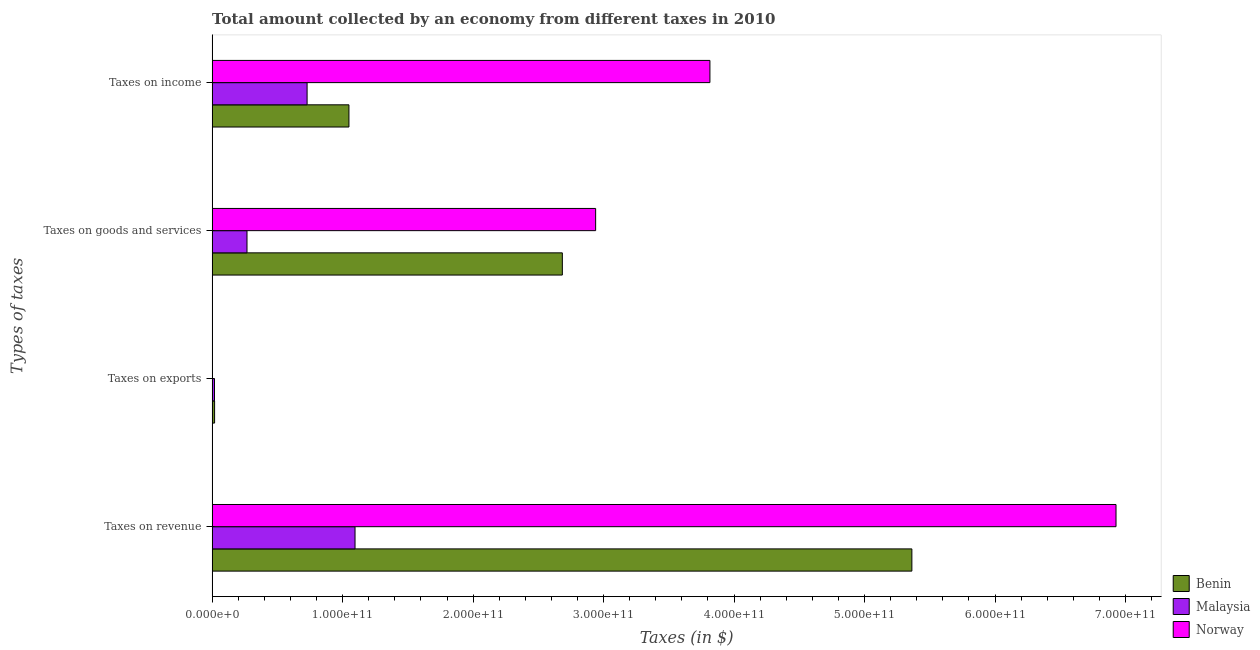How many groups of bars are there?
Keep it short and to the point. 4. Are the number of bars on each tick of the Y-axis equal?
Offer a terse response. Yes. What is the label of the 2nd group of bars from the top?
Provide a succinct answer. Taxes on goods and services. What is the amount collected as tax on income in Malaysia?
Your answer should be very brief. 7.28e+1. Across all countries, what is the maximum amount collected as tax on goods?
Provide a short and direct response. 2.94e+11. Across all countries, what is the minimum amount collected as tax on exports?
Your answer should be very brief. 1.50e+08. In which country was the amount collected as tax on exports maximum?
Your response must be concise. Benin. In which country was the amount collected as tax on income minimum?
Give a very brief answer. Malaysia. What is the total amount collected as tax on revenue in the graph?
Provide a succinct answer. 1.34e+12. What is the difference between the amount collected as tax on revenue in Malaysia and that in Norway?
Ensure brevity in your answer.  -5.83e+11. What is the difference between the amount collected as tax on revenue in Benin and the amount collected as tax on exports in Norway?
Offer a very short reply. 5.36e+11. What is the average amount collected as tax on goods per country?
Keep it short and to the point. 1.96e+11. What is the difference between the amount collected as tax on goods and amount collected as tax on income in Norway?
Your answer should be very brief. -8.76e+1. In how many countries, is the amount collected as tax on income greater than 700000000000 $?
Your answer should be compact. 0. What is the ratio of the amount collected as tax on revenue in Benin to that in Norway?
Provide a short and direct response. 0.77. Is the amount collected as tax on goods in Benin less than that in Malaysia?
Your answer should be compact. No. What is the difference between the highest and the second highest amount collected as tax on income?
Keep it short and to the point. 2.77e+11. What is the difference between the highest and the lowest amount collected as tax on exports?
Keep it short and to the point. 1.75e+09. In how many countries, is the amount collected as tax on exports greater than the average amount collected as tax on exports taken over all countries?
Your answer should be compact. 2. Is the sum of the amount collected as tax on income in Malaysia and Benin greater than the maximum amount collected as tax on revenue across all countries?
Your response must be concise. No. What does the 1st bar from the top in Taxes on exports represents?
Your response must be concise. Norway. What does the 1st bar from the bottom in Taxes on income represents?
Your answer should be compact. Benin. Are all the bars in the graph horizontal?
Provide a short and direct response. Yes. How many countries are there in the graph?
Ensure brevity in your answer.  3. What is the difference between two consecutive major ticks on the X-axis?
Your response must be concise. 1.00e+11. Are the values on the major ticks of X-axis written in scientific E-notation?
Ensure brevity in your answer.  Yes. Does the graph contain grids?
Ensure brevity in your answer.  No. Where does the legend appear in the graph?
Your response must be concise. Bottom right. How many legend labels are there?
Provide a succinct answer. 3. What is the title of the graph?
Provide a succinct answer. Total amount collected by an economy from different taxes in 2010. What is the label or title of the X-axis?
Offer a very short reply. Taxes (in $). What is the label or title of the Y-axis?
Offer a terse response. Types of taxes. What is the Taxes (in $) of Benin in Taxes on revenue?
Your answer should be compact. 5.36e+11. What is the Taxes (in $) in Malaysia in Taxes on revenue?
Your response must be concise. 1.10e+11. What is the Taxes (in $) in Norway in Taxes on revenue?
Ensure brevity in your answer.  6.93e+11. What is the Taxes (in $) of Benin in Taxes on exports?
Provide a succinct answer. 1.90e+09. What is the Taxes (in $) in Malaysia in Taxes on exports?
Offer a very short reply. 1.81e+09. What is the Taxes (in $) in Norway in Taxes on exports?
Provide a short and direct response. 1.50e+08. What is the Taxes (in $) in Benin in Taxes on goods and services?
Offer a terse response. 2.68e+11. What is the Taxes (in $) in Malaysia in Taxes on goods and services?
Offer a very short reply. 2.67e+1. What is the Taxes (in $) in Norway in Taxes on goods and services?
Offer a very short reply. 2.94e+11. What is the Taxes (in $) of Benin in Taxes on income?
Your answer should be very brief. 1.05e+11. What is the Taxes (in $) in Malaysia in Taxes on income?
Provide a short and direct response. 7.28e+1. What is the Taxes (in $) in Norway in Taxes on income?
Ensure brevity in your answer.  3.81e+11. Across all Types of taxes, what is the maximum Taxes (in $) in Benin?
Ensure brevity in your answer.  5.36e+11. Across all Types of taxes, what is the maximum Taxes (in $) of Malaysia?
Ensure brevity in your answer.  1.10e+11. Across all Types of taxes, what is the maximum Taxes (in $) in Norway?
Provide a succinct answer. 6.93e+11. Across all Types of taxes, what is the minimum Taxes (in $) in Benin?
Your response must be concise. 1.90e+09. Across all Types of taxes, what is the minimum Taxes (in $) of Malaysia?
Your answer should be very brief. 1.81e+09. Across all Types of taxes, what is the minimum Taxes (in $) in Norway?
Your answer should be very brief. 1.50e+08. What is the total Taxes (in $) of Benin in the graph?
Ensure brevity in your answer.  9.11e+11. What is the total Taxes (in $) in Malaysia in the graph?
Offer a very short reply. 2.11e+11. What is the total Taxes (in $) of Norway in the graph?
Offer a terse response. 1.37e+12. What is the difference between the Taxes (in $) of Benin in Taxes on revenue and that in Taxes on exports?
Offer a very short reply. 5.34e+11. What is the difference between the Taxes (in $) of Malaysia in Taxes on revenue and that in Taxes on exports?
Your response must be concise. 1.08e+11. What is the difference between the Taxes (in $) of Norway in Taxes on revenue and that in Taxes on exports?
Offer a terse response. 6.93e+11. What is the difference between the Taxes (in $) of Benin in Taxes on revenue and that in Taxes on goods and services?
Offer a very short reply. 2.68e+11. What is the difference between the Taxes (in $) of Malaysia in Taxes on revenue and that in Taxes on goods and services?
Make the answer very short. 8.28e+1. What is the difference between the Taxes (in $) in Norway in Taxes on revenue and that in Taxes on goods and services?
Give a very brief answer. 3.99e+11. What is the difference between the Taxes (in $) of Benin in Taxes on revenue and that in Taxes on income?
Ensure brevity in your answer.  4.31e+11. What is the difference between the Taxes (in $) of Malaysia in Taxes on revenue and that in Taxes on income?
Keep it short and to the point. 3.67e+1. What is the difference between the Taxes (in $) of Norway in Taxes on revenue and that in Taxes on income?
Offer a very short reply. 3.11e+11. What is the difference between the Taxes (in $) of Benin in Taxes on exports and that in Taxes on goods and services?
Your answer should be very brief. -2.66e+11. What is the difference between the Taxes (in $) of Malaysia in Taxes on exports and that in Taxes on goods and services?
Give a very brief answer. -2.49e+1. What is the difference between the Taxes (in $) of Norway in Taxes on exports and that in Taxes on goods and services?
Provide a short and direct response. -2.94e+11. What is the difference between the Taxes (in $) of Benin in Taxes on exports and that in Taxes on income?
Ensure brevity in your answer.  -1.03e+11. What is the difference between the Taxes (in $) in Malaysia in Taxes on exports and that in Taxes on income?
Make the answer very short. -7.10e+1. What is the difference between the Taxes (in $) in Norway in Taxes on exports and that in Taxes on income?
Provide a succinct answer. -3.81e+11. What is the difference between the Taxes (in $) of Benin in Taxes on goods and services and that in Taxes on income?
Your answer should be compact. 1.64e+11. What is the difference between the Taxes (in $) in Malaysia in Taxes on goods and services and that in Taxes on income?
Keep it short and to the point. -4.61e+1. What is the difference between the Taxes (in $) of Norway in Taxes on goods and services and that in Taxes on income?
Make the answer very short. -8.76e+1. What is the difference between the Taxes (in $) in Benin in Taxes on revenue and the Taxes (in $) in Malaysia in Taxes on exports?
Provide a succinct answer. 5.34e+11. What is the difference between the Taxes (in $) of Benin in Taxes on revenue and the Taxes (in $) of Norway in Taxes on exports?
Your answer should be very brief. 5.36e+11. What is the difference between the Taxes (in $) in Malaysia in Taxes on revenue and the Taxes (in $) in Norway in Taxes on exports?
Ensure brevity in your answer.  1.09e+11. What is the difference between the Taxes (in $) in Benin in Taxes on revenue and the Taxes (in $) in Malaysia in Taxes on goods and services?
Give a very brief answer. 5.10e+11. What is the difference between the Taxes (in $) in Benin in Taxes on revenue and the Taxes (in $) in Norway in Taxes on goods and services?
Your answer should be very brief. 2.42e+11. What is the difference between the Taxes (in $) of Malaysia in Taxes on revenue and the Taxes (in $) of Norway in Taxes on goods and services?
Ensure brevity in your answer.  -1.84e+11. What is the difference between the Taxes (in $) of Benin in Taxes on revenue and the Taxes (in $) of Malaysia in Taxes on income?
Give a very brief answer. 4.63e+11. What is the difference between the Taxes (in $) in Benin in Taxes on revenue and the Taxes (in $) in Norway in Taxes on income?
Offer a very short reply. 1.55e+11. What is the difference between the Taxes (in $) of Malaysia in Taxes on revenue and the Taxes (in $) of Norway in Taxes on income?
Your answer should be very brief. -2.72e+11. What is the difference between the Taxes (in $) in Benin in Taxes on exports and the Taxes (in $) in Malaysia in Taxes on goods and services?
Make the answer very short. -2.48e+1. What is the difference between the Taxes (in $) of Benin in Taxes on exports and the Taxes (in $) of Norway in Taxes on goods and services?
Give a very brief answer. -2.92e+11. What is the difference between the Taxes (in $) of Malaysia in Taxes on exports and the Taxes (in $) of Norway in Taxes on goods and services?
Your answer should be very brief. -2.92e+11. What is the difference between the Taxes (in $) of Benin in Taxes on exports and the Taxes (in $) of Malaysia in Taxes on income?
Provide a short and direct response. -7.09e+1. What is the difference between the Taxes (in $) in Benin in Taxes on exports and the Taxes (in $) in Norway in Taxes on income?
Provide a succinct answer. -3.80e+11. What is the difference between the Taxes (in $) in Malaysia in Taxes on exports and the Taxes (in $) in Norway in Taxes on income?
Your response must be concise. -3.80e+11. What is the difference between the Taxes (in $) in Benin in Taxes on goods and services and the Taxes (in $) in Malaysia in Taxes on income?
Your response must be concise. 1.96e+11. What is the difference between the Taxes (in $) of Benin in Taxes on goods and services and the Taxes (in $) of Norway in Taxes on income?
Give a very brief answer. -1.13e+11. What is the difference between the Taxes (in $) of Malaysia in Taxes on goods and services and the Taxes (in $) of Norway in Taxes on income?
Make the answer very short. -3.55e+11. What is the average Taxes (in $) of Benin per Types of taxes?
Keep it short and to the point. 2.28e+11. What is the average Taxes (in $) of Malaysia per Types of taxes?
Ensure brevity in your answer.  5.27e+1. What is the average Taxes (in $) of Norway per Types of taxes?
Make the answer very short. 3.42e+11. What is the difference between the Taxes (in $) in Benin and Taxes (in $) in Malaysia in Taxes on revenue?
Offer a very short reply. 4.27e+11. What is the difference between the Taxes (in $) in Benin and Taxes (in $) in Norway in Taxes on revenue?
Offer a terse response. -1.56e+11. What is the difference between the Taxes (in $) of Malaysia and Taxes (in $) of Norway in Taxes on revenue?
Ensure brevity in your answer.  -5.83e+11. What is the difference between the Taxes (in $) of Benin and Taxes (in $) of Malaysia in Taxes on exports?
Your answer should be very brief. 8.53e+07. What is the difference between the Taxes (in $) of Benin and Taxes (in $) of Norway in Taxes on exports?
Offer a terse response. 1.75e+09. What is the difference between the Taxes (in $) in Malaysia and Taxes (in $) in Norway in Taxes on exports?
Keep it short and to the point. 1.66e+09. What is the difference between the Taxes (in $) of Benin and Taxes (in $) of Malaysia in Taxes on goods and services?
Keep it short and to the point. 2.42e+11. What is the difference between the Taxes (in $) in Benin and Taxes (in $) in Norway in Taxes on goods and services?
Provide a succinct answer. -2.55e+1. What is the difference between the Taxes (in $) of Malaysia and Taxes (in $) of Norway in Taxes on goods and services?
Your answer should be very brief. -2.67e+11. What is the difference between the Taxes (in $) of Benin and Taxes (in $) of Malaysia in Taxes on income?
Offer a very short reply. 3.21e+1. What is the difference between the Taxes (in $) in Benin and Taxes (in $) in Norway in Taxes on income?
Make the answer very short. -2.77e+11. What is the difference between the Taxes (in $) in Malaysia and Taxes (in $) in Norway in Taxes on income?
Offer a terse response. -3.09e+11. What is the ratio of the Taxes (in $) of Benin in Taxes on revenue to that in Taxes on exports?
Provide a short and direct response. 282.91. What is the ratio of the Taxes (in $) in Malaysia in Taxes on revenue to that in Taxes on exports?
Offer a very short reply. 60.5. What is the ratio of the Taxes (in $) in Norway in Taxes on revenue to that in Taxes on exports?
Offer a terse response. 4618. What is the ratio of the Taxes (in $) of Benin in Taxes on revenue to that in Taxes on goods and services?
Ensure brevity in your answer.  2. What is the ratio of the Taxes (in $) of Malaysia in Taxes on revenue to that in Taxes on goods and services?
Keep it short and to the point. 4.1. What is the ratio of the Taxes (in $) of Norway in Taxes on revenue to that in Taxes on goods and services?
Ensure brevity in your answer.  2.36. What is the ratio of the Taxes (in $) in Benin in Taxes on revenue to that in Taxes on income?
Your response must be concise. 5.11. What is the ratio of the Taxes (in $) of Malaysia in Taxes on revenue to that in Taxes on income?
Ensure brevity in your answer.  1.5. What is the ratio of the Taxes (in $) of Norway in Taxes on revenue to that in Taxes on income?
Your answer should be compact. 1.82. What is the ratio of the Taxes (in $) in Benin in Taxes on exports to that in Taxes on goods and services?
Your answer should be compact. 0.01. What is the ratio of the Taxes (in $) of Malaysia in Taxes on exports to that in Taxes on goods and services?
Your response must be concise. 0.07. What is the ratio of the Taxes (in $) in Benin in Taxes on exports to that in Taxes on income?
Your answer should be very brief. 0.02. What is the ratio of the Taxes (in $) in Malaysia in Taxes on exports to that in Taxes on income?
Give a very brief answer. 0.02. What is the ratio of the Taxes (in $) in Norway in Taxes on exports to that in Taxes on income?
Offer a very short reply. 0. What is the ratio of the Taxes (in $) of Benin in Taxes on goods and services to that in Taxes on income?
Offer a very short reply. 2.56. What is the ratio of the Taxes (in $) of Malaysia in Taxes on goods and services to that in Taxes on income?
Give a very brief answer. 0.37. What is the ratio of the Taxes (in $) of Norway in Taxes on goods and services to that in Taxes on income?
Provide a short and direct response. 0.77. What is the difference between the highest and the second highest Taxes (in $) in Benin?
Offer a very short reply. 2.68e+11. What is the difference between the highest and the second highest Taxes (in $) of Malaysia?
Provide a succinct answer. 3.67e+1. What is the difference between the highest and the second highest Taxes (in $) of Norway?
Make the answer very short. 3.11e+11. What is the difference between the highest and the lowest Taxes (in $) of Benin?
Offer a terse response. 5.34e+11. What is the difference between the highest and the lowest Taxes (in $) of Malaysia?
Make the answer very short. 1.08e+11. What is the difference between the highest and the lowest Taxes (in $) in Norway?
Your response must be concise. 6.93e+11. 